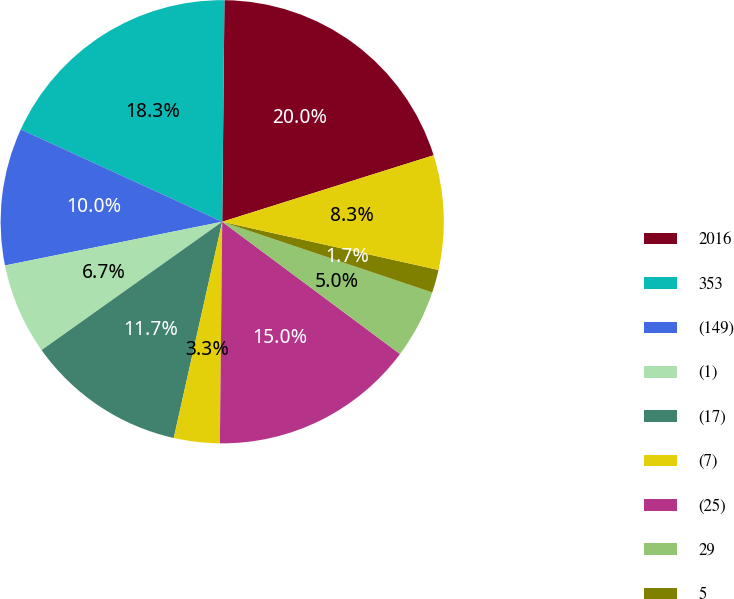Convert chart to OTSL. <chart><loc_0><loc_0><loc_500><loc_500><pie_chart><fcel>2016<fcel>353<fcel>(149)<fcel>(1)<fcel>(17)<fcel>(7)<fcel>(25)<fcel>29<fcel>5<fcel>42<nl><fcel>19.99%<fcel>18.32%<fcel>10.0%<fcel>6.67%<fcel>11.66%<fcel>3.34%<fcel>14.99%<fcel>5.01%<fcel>1.68%<fcel>8.34%<nl></chart> 